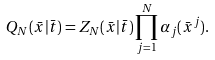Convert formula to latex. <formula><loc_0><loc_0><loc_500><loc_500>Q _ { N } ( \bar { x } | \bar { t } ) = Z _ { N } ( \bar { x } | \bar { t } ) \prod _ { j = 1 } ^ { N } \alpha _ { j } ( \bar { x } ^ { j } ) .</formula> 